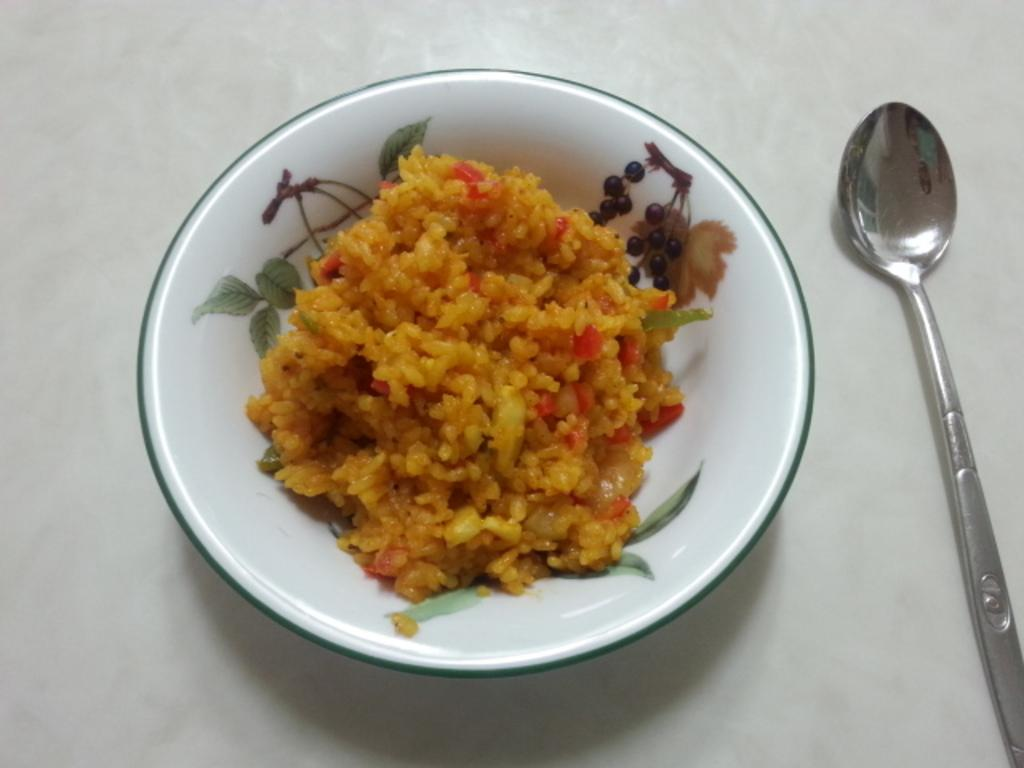What is in the bowl that is visible in the image? There is rice in the bowl. What is the color of the surface the bowl is placed on? The bowl is on a white surface. What utensil is located beside the bowl? There is a spoon beside the bowl. How many dimes are visible in the image? There are no dimes present in the image. What expertise does the person in the image have? There is no person present in the image, so it is impossible to determine their expertise. 